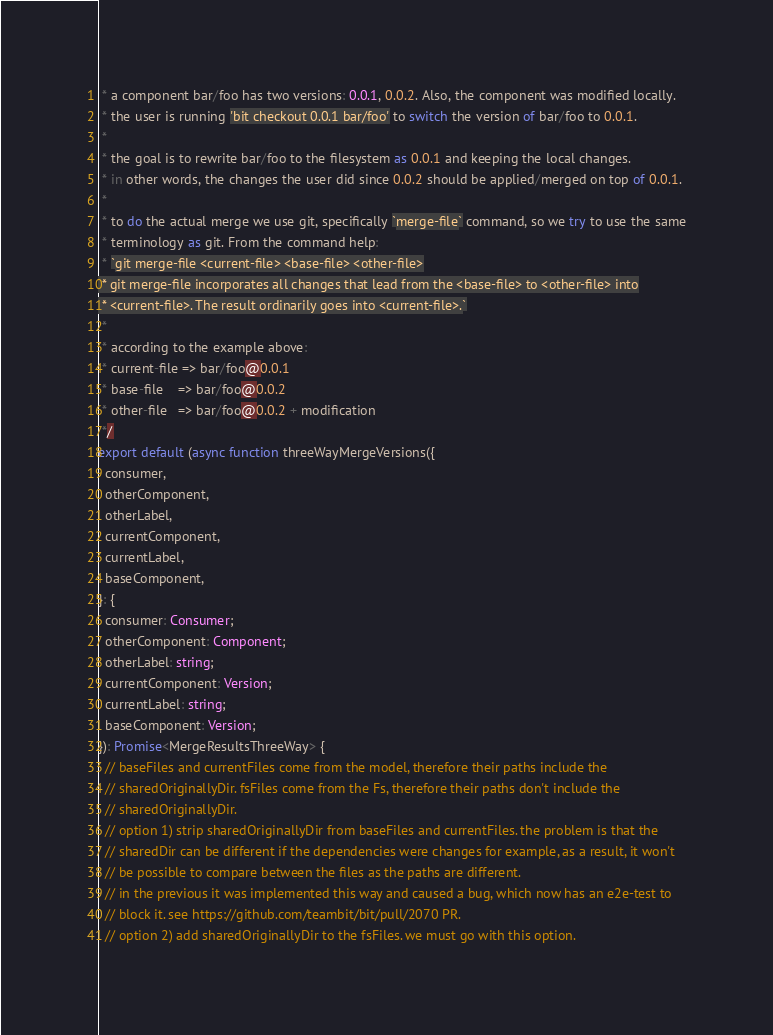<code> <loc_0><loc_0><loc_500><loc_500><_TypeScript_> * a component bar/foo has two versions: 0.0.1, 0.0.2. Also, the component was modified locally.
 * the user is running 'bit checkout 0.0.1 bar/foo' to switch the version of bar/foo to 0.0.1.
 *
 * the goal is to rewrite bar/foo to the filesystem as 0.0.1 and keeping the local changes.
 * in other words, the changes the user did since 0.0.2 should be applied/merged on top of 0.0.1.
 *
 * to do the actual merge we use git, specifically `merge-file` command, so we try to use the same
 * terminology as git. From the command help:
 * `git merge-file <current-file> <base-file> <other-file>
 * git merge-file incorporates all changes that lead from the <base-file> to <other-file> into
 * <current-file>. The result ordinarily goes into <current-file>.`
 *
 * according to the example above:
 * current-file => bar/foo@0.0.1
 * base-file    => bar/foo@0.0.2
 * other-file   => bar/foo@0.0.2 + modification
 */
export default (async function threeWayMergeVersions({
  consumer,
  otherComponent,
  otherLabel,
  currentComponent,
  currentLabel,
  baseComponent,
}: {
  consumer: Consumer;
  otherComponent: Component;
  otherLabel: string;
  currentComponent: Version;
  currentLabel: string;
  baseComponent: Version;
}): Promise<MergeResultsThreeWay> {
  // baseFiles and currentFiles come from the model, therefore their paths include the
  // sharedOriginallyDir. fsFiles come from the Fs, therefore their paths don't include the
  // sharedOriginallyDir.
  // option 1) strip sharedOriginallyDir from baseFiles and currentFiles. the problem is that the
  // sharedDir can be different if the dependencies were changes for example, as a result, it won't
  // be possible to compare between the files as the paths are different.
  // in the previous it was implemented this way and caused a bug, which now has an e2e-test to
  // block it. see https://github.com/teambit/bit/pull/2070 PR.
  // option 2) add sharedOriginallyDir to the fsFiles. we must go with this option.</code> 